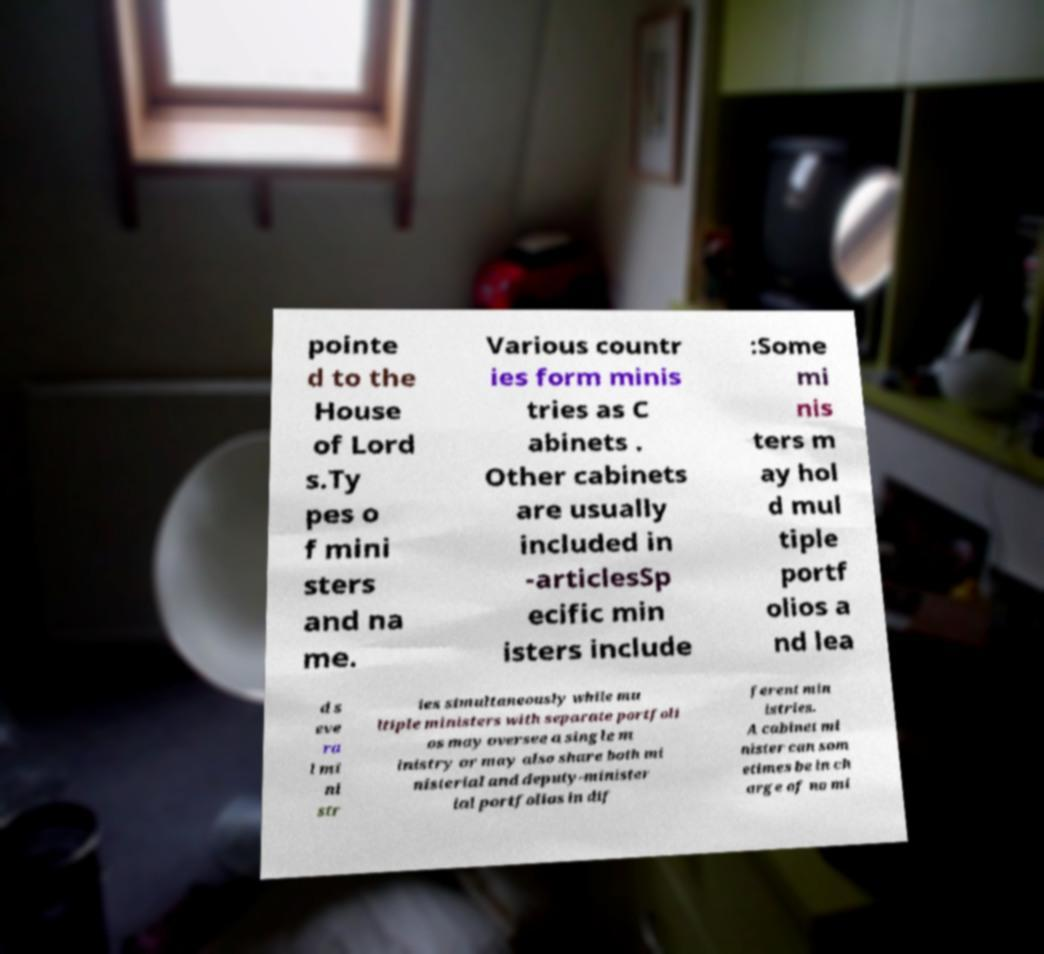Could you extract and type out the text from this image? pointe d to the House of Lord s.Ty pes o f mini sters and na me. Various countr ies form minis tries as C abinets . Other cabinets are usually included in -articlesSp ecific min isters include :Some mi nis ters m ay hol d mul tiple portf olios a nd lea d s eve ra l mi ni str ies simultaneously while mu ltiple ministers with separate portfoli os may oversee a single m inistry or may also share both mi nisterial and deputy-minister ial portfolios in dif ferent min istries. A cabinet mi nister can som etimes be in ch arge of no mi 